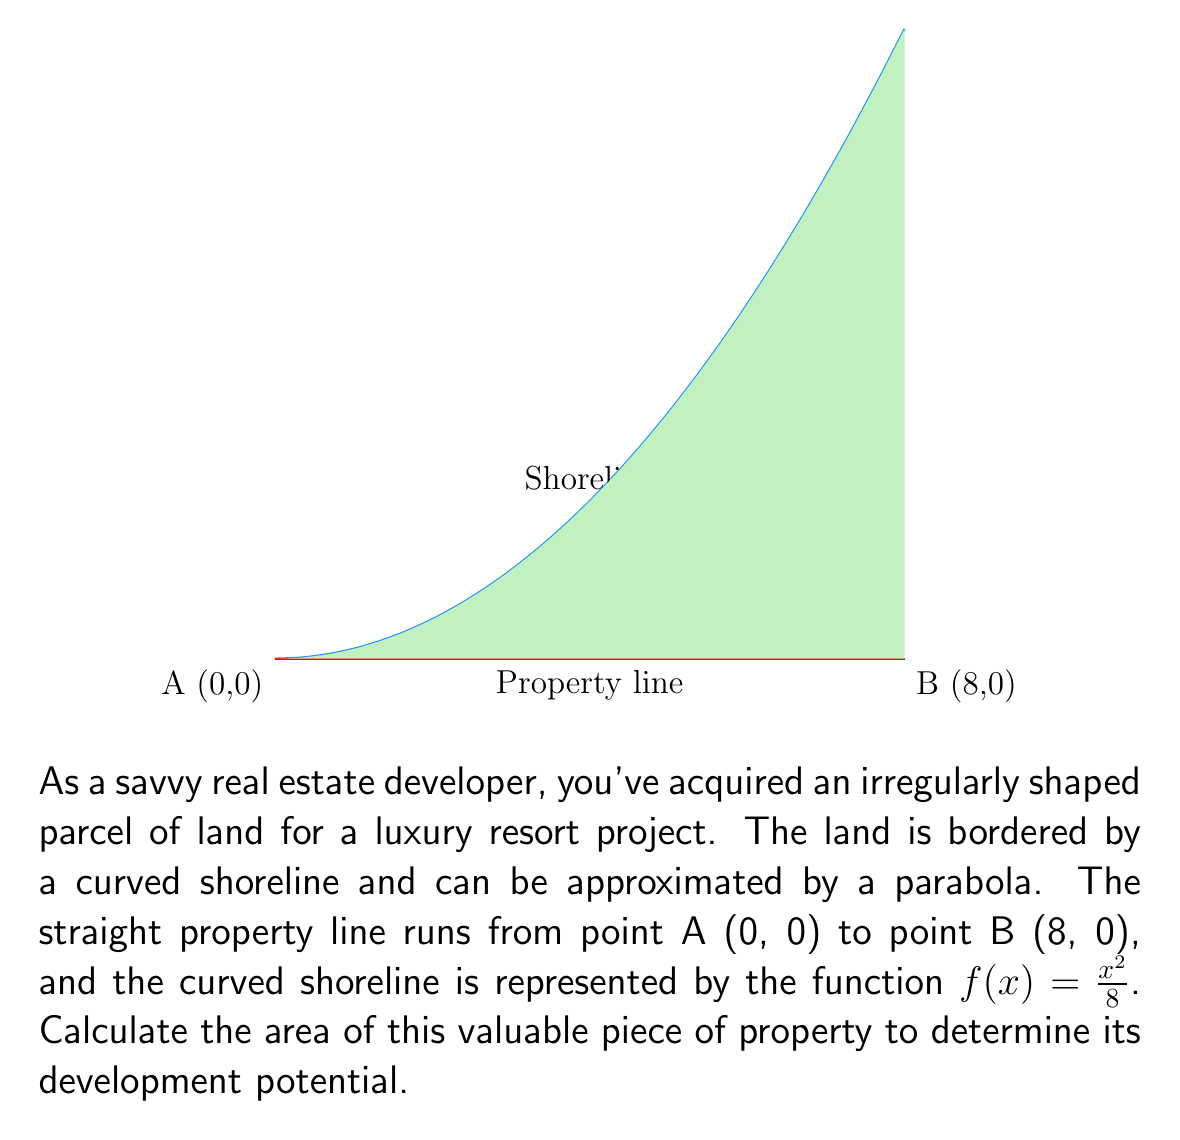Can you solve this math problem? To calculate the area of this irregularly shaped land parcel, we need to use integral calculus. The area is bounded by the parabola $f(x) = x^2/8$ and the x-axis from x = 0 to x = 8.

Step 1: Set up the integral
The area is given by the definite integral:

$$A = \int_{0}^{8} f(x) dx = \int_{0}^{8} \frac{x^2}{8} dx$$

Step 2: Evaluate the integral
$$\begin{align}
A &= \int_{0}^{8} \frac{x^2}{8} dx \\
&= \frac{1}{8} \int_{0}^{8} x^2 dx \\
&= \frac{1}{8} \left[ \frac{x^3}{3} \right]_{0}^{8} \\
&= \frac{1}{8} \left( \frac{8^3}{3} - \frac{0^3}{3} \right) \\
&= \frac{1}{8} \cdot \frac{512}{3} \\
&= \frac{64}{3} \\
&\approx 21.33
\end{align}$$

Step 3: Interpret the result
The area of the land parcel is $\frac{64}{3}$ square units, which is approximately 21.33 square units.
Answer: $\frac{64}{3}$ square units 